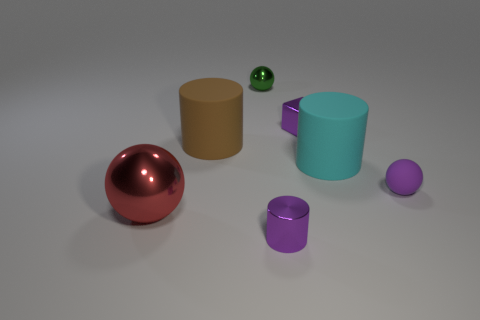Subtract 1 cylinders. How many cylinders are left? 2 Subtract all green metallic spheres. How many spheres are left? 2 Add 3 brown matte cylinders. How many objects exist? 10 Subtract all yellow balls. Subtract all gray cubes. How many balls are left? 3 Add 4 brown rubber objects. How many brown rubber objects exist? 5 Subtract 1 purple cubes. How many objects are left? 6 Subtract all blocks. How many objects are left? 6 Subtract all metallic balls. Subtract all purple metal cylinders. How many objects are left? 4 Add 6 purple rubber things. How many purple rubber things are left? 7 